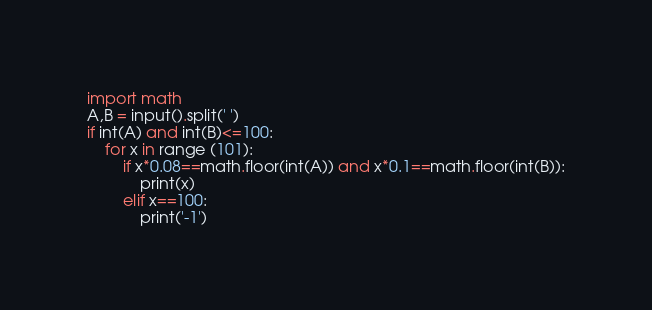<code> <loc_0><loc_0><loc_500><loc_500><_Python_>import math
A,B = input().split(' ')
if int(A) and int(B)<=100:
    for x in range (101):
        if x*0.08==math.floor(int(A)) and x*0.1==math.floor(int(B)):
            print(x)
        elif x==100:
            print('-1')</code> 